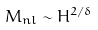Convert formula to latex. <formula><loc_0><loc_0><loc_500><loc_500>M _ { n l } \sim H ^ { 2 / \delta }</formula> 